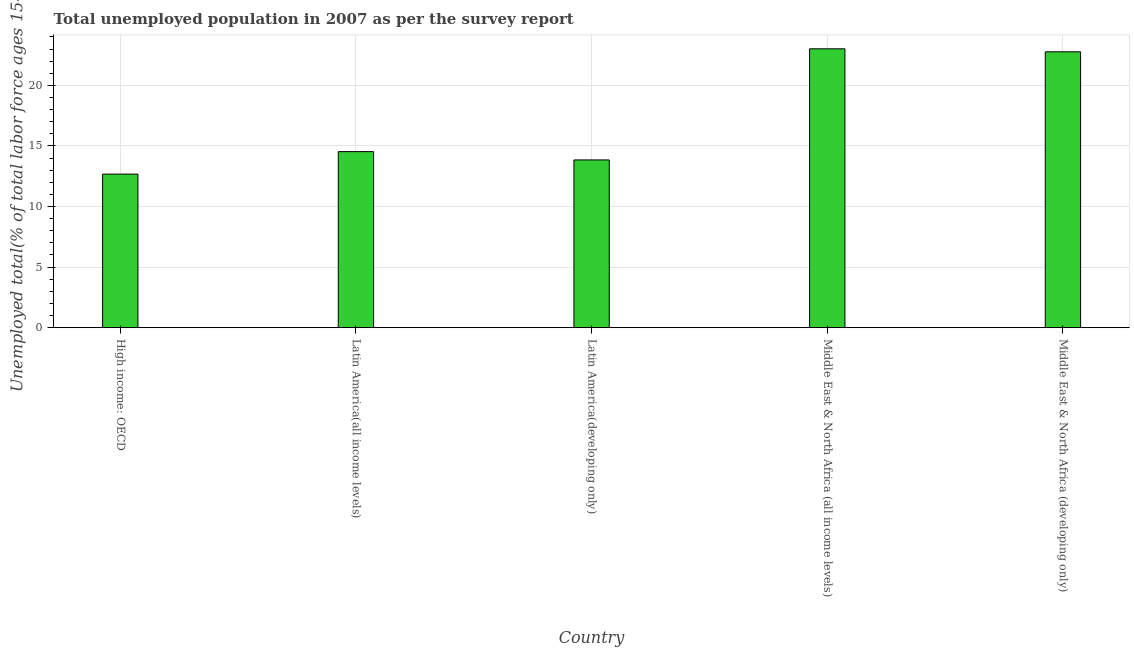Does the graph contain grids?
Provide a succinct answer. Yes. What is the title of the graph?
Keep it short and to the point. Total unemployed population in 2007 as per the survey report. What is the label or title of the Y-axis?
Ensure brevity in your answer.  Unemployed total(% of total labor force ages 15-24). What is the unemployed youth in Middle East & North Africa (all income levels)?
Provide a succinct answer. 23.02. Across all countries, what is the maximum unemployed youth?
Your response must be concise. 23.02. Across all countries, what is the minimum unemployed youth?
Ensure brevity in your answer.  12.68. In which country was the unemployed youth maximum?
Give a very brief answer. Middle East & North Africa (all income levels). In which country was the unemployed youth minimum?
Offer a terse response. High income: OECD. What is the sum of the unemployed youth?
Keep it short and to the point. 86.86. What is the difference between the unemployed youth in Middle East & North Africa (all income levels) and Middle East & North Africa (developing only)?
Keep it short and to the point. 0.25. What is the average unemployed youth per country?
Give a very brief answer. 17.37. What is the median unemployed youth?
Provide a succinct answer. 14.53. What is the ratio of the unemployed youth in High income: OECD to that in Latin America(developing only)?
Make the answer very short. 0.92. What is the difference between the highest and the second highest unemployed youth?
Provide a succinct answer. 0.25. Is the sum of the unemployed youth in Middle East & North Africa (all income levels) and Middle East & North Africa (developing only) greater than the maximum unemployed youth across all countries?
Your answer should be very brief. Yes. What is the difference between the highest and the lowest unemployed youth?
Your answer should be compact. 10.34. Are the values on the major ticks of Y-axis written in scientific E-notation?
Your answer should be very brief. No. What is the Unemployed total(% of total labor force ages 15-24) of High income: OECD?
Offer a terse response. 12.68. What is the Unemployed total(% of total labor force ages 15-24) of Latin America(all income levels)?
Your answer should be very brief. 14.53. What is the Unemployed total(% of total labor force ages 15-24) in Latin America(developing only)?
Offer a very short reply. 13.85. What is the Unemployed total(% of total labor force ages 15-24) in Middle East & North Africa (all income levels)?
Your answer should be very brief. 23.02. What is the Unemployed total(% of total labor force ages 15-24) of Middle East & North Africa (developing only)?
Ensure brevity in your answer.  22.77. What is the difference between the Unemployed total(% of total labor force ages 15-24) in High income: OECD and Latin America(all income levels)?
Offer a terse response. -1.85. What is the difference between the Unemployed total(% of total labor force ages 15-24) in High income: OECD and Latin America(developing only)?
Keep it short and to the point. -1.17. What is the difference between the Unemployed total(% of total labor force ages 15-24) in High income: OECD and Middle East & North Africa (all income levels)?
Offer a very short reply. -10.34. What is the difference between the Unemployed total(% of total labor force ages 15-24) in High income: OECD and Middle East & North Africa (developing only)?
Your answer should be compact. -10.1. What is the difference between the Unemployed total(% of total labor force ages 15-24) in Latin America(all income levels) and Latin America(developing only)?
Ensure brevity in your answer.  0.69. What is the difference between the Unemployed total(% of total labor force ages 15-24) in Latin America(all income levels) and Middle East & North Africa (all income levels)?
Your answer should be compact. -8.49. What is the difference between the Unemployed total(% of total labor force ages 15-24) in Latin America(all income levels) and Middle East & North Africa (developing only)?
Provide a short and direct response. -8.24. What is the difference between the Unemployed total(% of total labor force ages 15-24) in Latin America(developing only) and Middle East & North Africa (all income levels)?
Your response must be concise. -9.17. What is the difference between the Unemployed total(% of total labor force ages 15-24) in Latin America(developing only) and Middle East & North Africa (developing only)?
Ensure brevity in your answer.  -8.93. What is the difference between the Unemployed total(% of total labor force ages 15-24) in Middle East & North Africa (all income levels) and Middle East & North Africa (developing only)?
Ensure brevity in your answer.  0.25. What is the ratio of the Unemployed total(% of total labor force ages 15-24) in High income: OECD to that in Latin America(all income levels)?
Your response must be concise. 0.87. What is the ratio of the Unemployed total(% of total labor force ages 15-24) in High income: OECD to that in Latin America(developing only)?
Provide a short and direct response. 0.92. What is the ratio of the Unemployed total(% of total labor force ages 15-24) in High income: OECD to that in Middle East & North Africa (all income levels)?
Offer a terse response. 0.55. What is the ratio of the Unemployed total(% of total labor force ages 15-24) in High income: OECD to that in Middle East & North Africa (developing only)?
Keep it short and to the point. 0.56. What is the ratio of the Unemployed total(% of total labor force ages 15-24) in Latin America(all income levels) to that in Latin America(developing only)?
Give a very brief answer. 1.05. What is the ratio of the Unemployed total(% of total labor force ages 15-24) in Latin America(all income levels) to that in Middle East & North Africa (all income levels)?
Ensure brevity in your answer.  0.63. What is the ratio of the Unemployed total(% of total labor force ages 15-24) in Latin America(all income levels) to that in Middle East & North Africa (developing only)?
Offer a very short reply. 0.64. What is the ratio of the Unemployed total(% of total labor force ages 15-24) in Latin America(developing only) to that in Middle East & North Africa (all income levels)?
Give a very brief answer. 0.6. What is the ratio of the Unemployed total(% of total labor force ages 15-24) in Latin America(developing only) to that in Middle East & North Africa (developing only)?
Your answer should be compact. 0.61. 